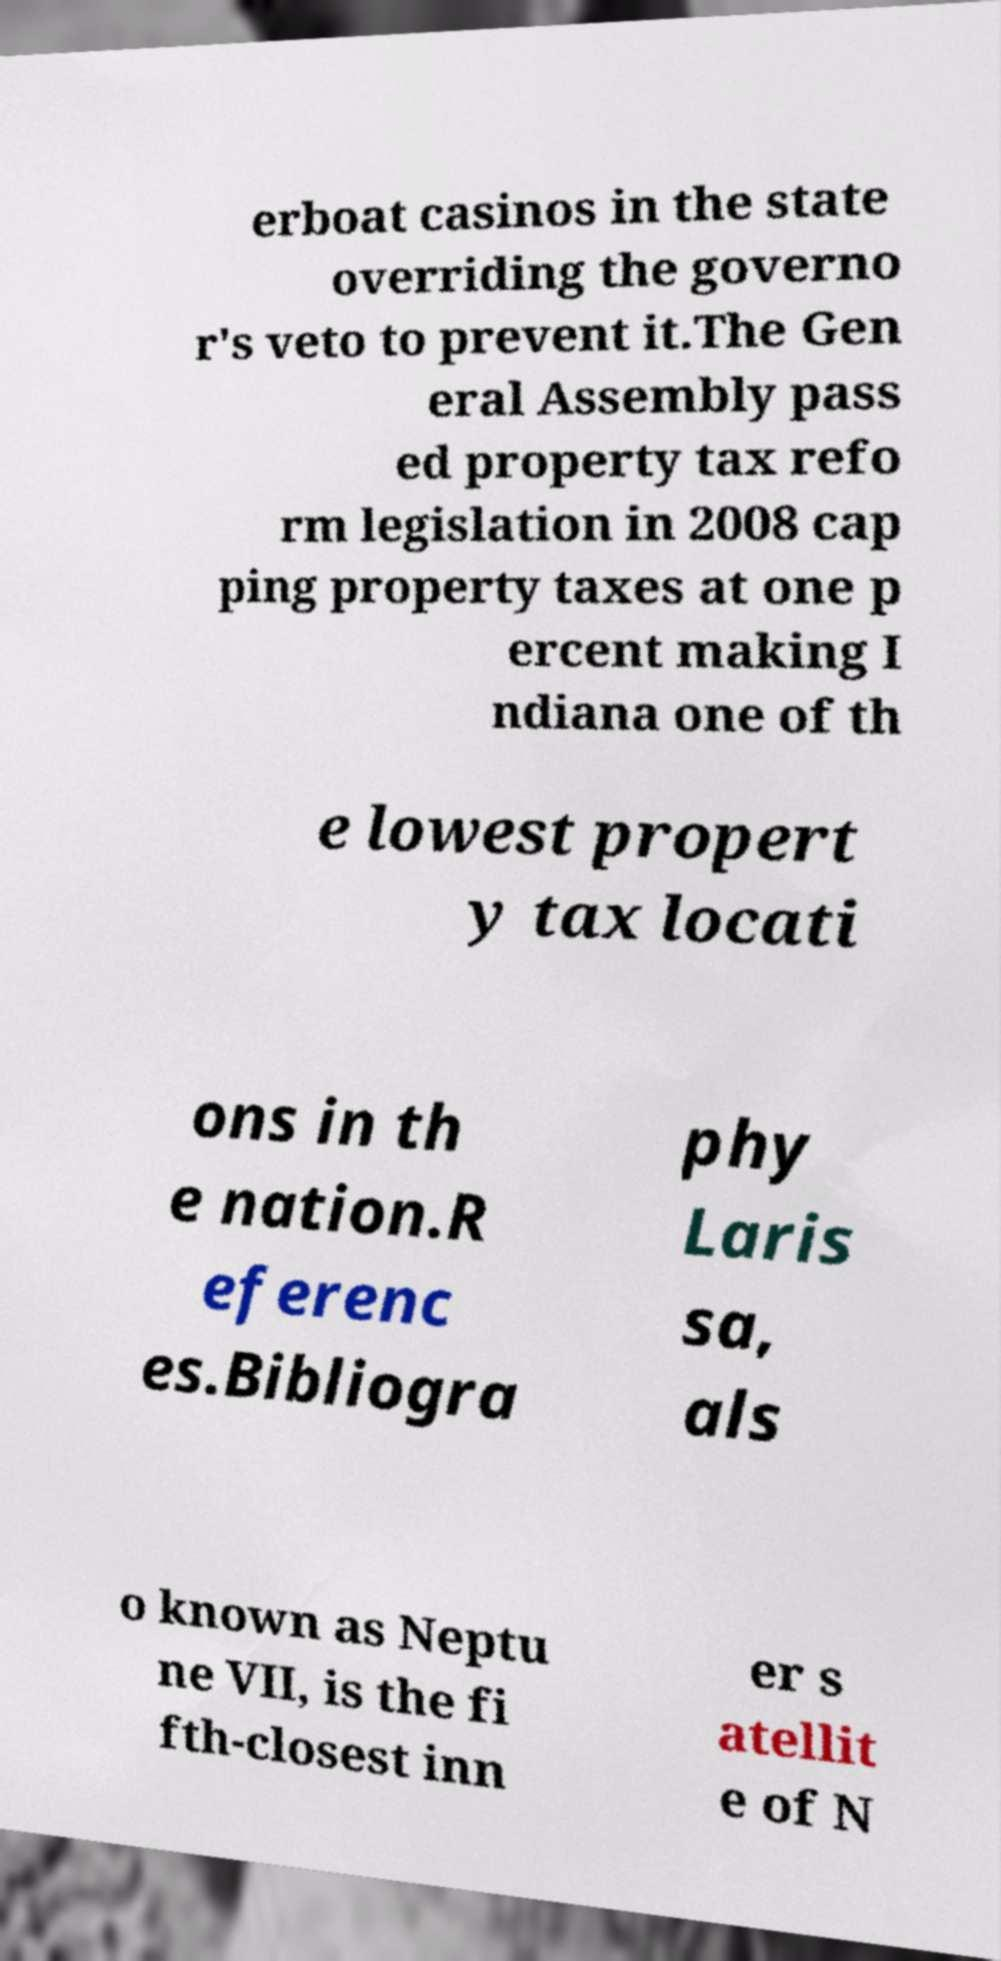There's text embedded in this image that I need extracted. Can you transcribe it verbatim? erboat casinos in the state overriding the governo r's veto to prevent it.The Gen eral Assembly pass ed property tax refo rm legislation in 2008 cap ping property taxes at one p ercent making I ndiana one of th e lowest propert y tax locati ons in th e nation.R eferenc es.Bibliogra phy Laris sa, als o known as Neptu ne VII, is the fi fth-closest inn er s atellit e of N 